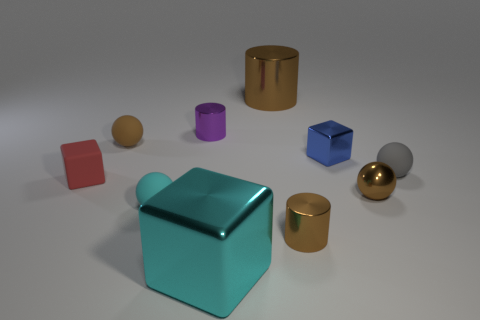There is a blue metallic object; is its size the same as the brown ball to the right of the big cyan metal cube?
Your answer should be very brief. Yes. How many things are either brown metallic cylinders or small brown metal spheres?
Ensure brevity in your answer.  3. Is there a brown sphere made of the same material as the tiny purple object?
Provide a short and direct response. Yes. There is a shiny sphere that is the same color as the large cylinder; what is its size?
Offer a terse response. Small. The tiny cube that is on the right side of the tiny cylinder behind the blue metal thing is what color?
Offer a very short reply. Blue. Is the size of the cyan cube the same as the purple metal cylinder?
Provide a short and direct response. No. How many balls are either big metallic things or tiny red matte things?
Provide a short and direct response. 0. There is a shiny block that is behind the small red object; what number of large brown cylinders are in front of it?
Your answer should be compact. 0. Is the red thing the same shape as the big brown thing?
Ensure brevity in your answer.  No. What is the size of the cyan matte thing that is the same shape as the small brown rubber thing?
Keep it short and to the point. Small. 